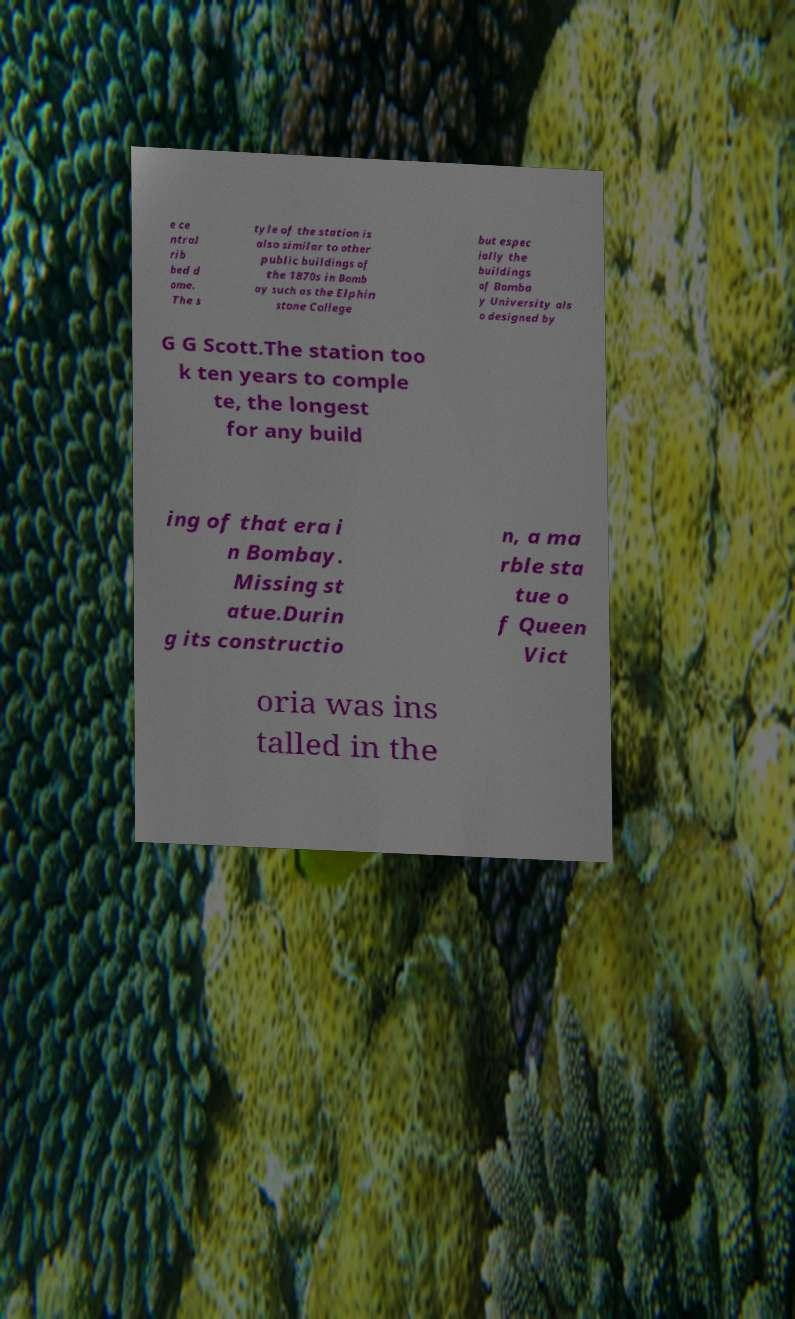Can you read and provide the text displayed in the image?This photo seems to have some interesting text. Can you extract and type it out for me? e ce ntral rib bed d ome. The s tyle of the station is also similar to other public buildings of the 1870s in Bomb ay such as the Elphin stone College but espec ially the buildings of Bomba y University als o designed by G G Scott.The station too k ten years to comple te, the longest for any build ing of that era i n Bombay. Missing st atue.Durin g its constructio n, a ma rble sta tue o f Queen Vict oria was ins talled in the 